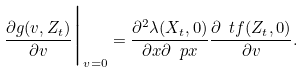Convert formula to latex. <formula><loc_0><loc_0><loc_500><loc_500>\frac { \partial g ( v , Z _ { t } ) } { \partial v } \Big | _ { v = 0 } = \frac { \partial ^ { 2 } \lambda ( X _ { t } , 0 ) } { \partial x \partial \ p x } \frac { \partial \ t f ( Z _ { t } , 0 ) } { \partial v } .</formula> 